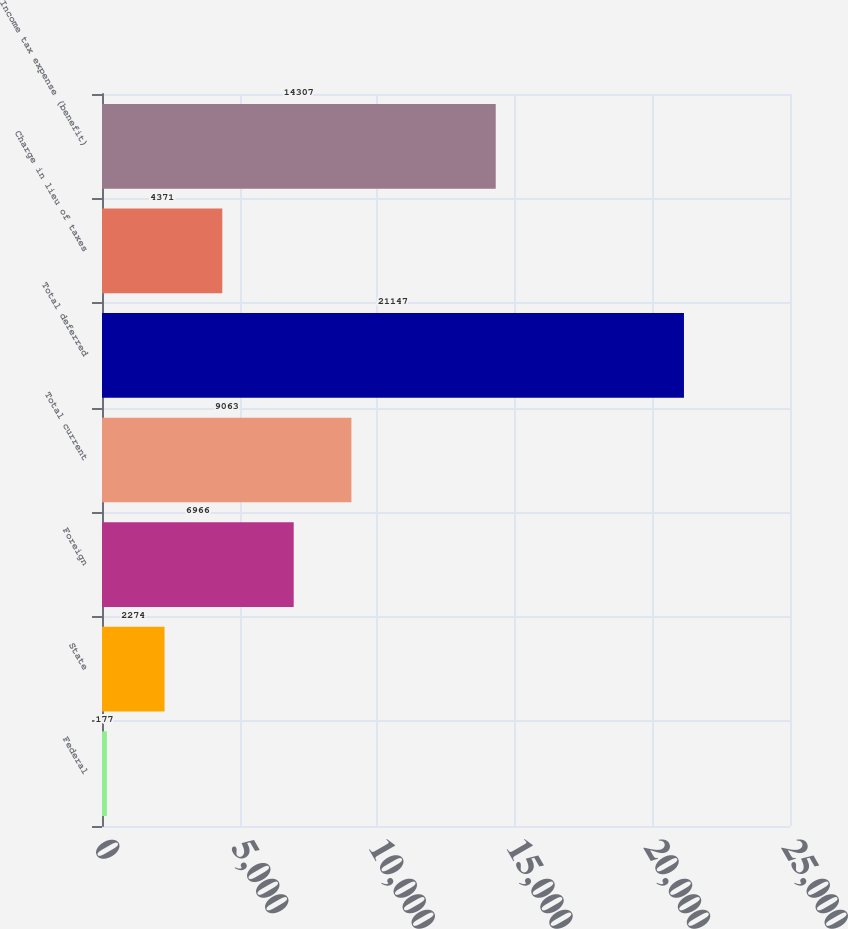<chart> <loc_0><loc_0><loc_500><loc_500><bar_chart><fcel>Federal<fcel>State<fcel>Foreign<fcel>Total current<fcel>Total deferred<fcel>Charge in lieu of taxes<fcel>Income tax expense (benefit)<nl><fcel>177<fcel>2274<fcel>6966<fcel>9063<fcel>21147<fcel>4371<fcel>14307<nl></chart> 